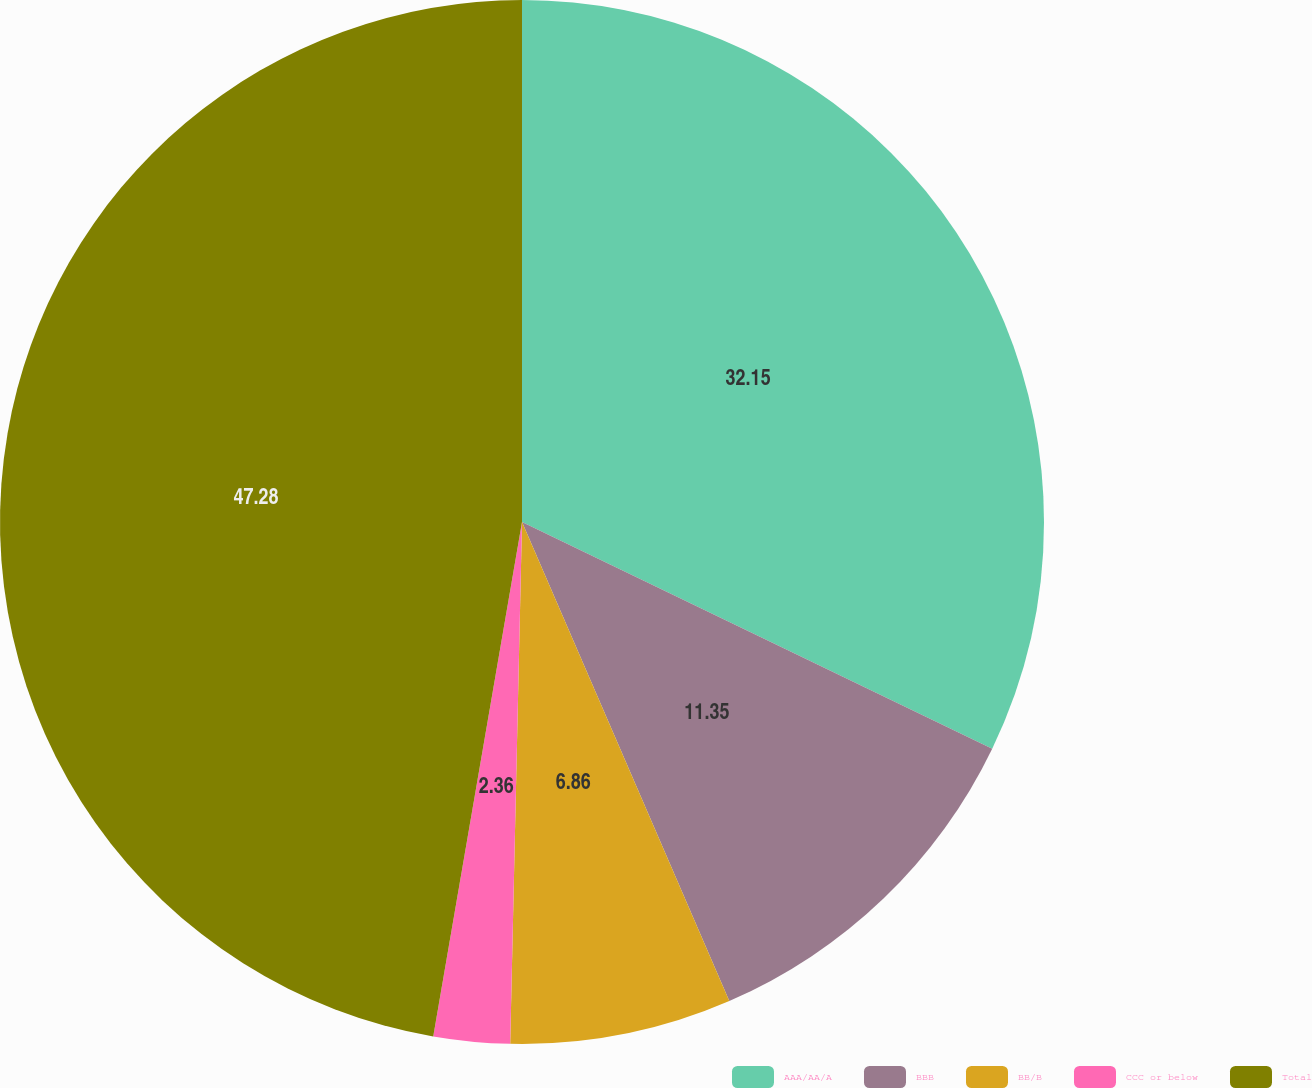Convert chart to OTSL. <chart><loc_0><loc_0><loc_500><loc_500><pie_chart><fcel>AAA/AA/A<fcel>BBB<fcel>BB/B<fcel>CCC or below<fcel>Total<nl><fcel>32.15%<fcel>11.35%<fcel>6.86%<fcel>2.36%<fcel>47.28%<nl></chart> 